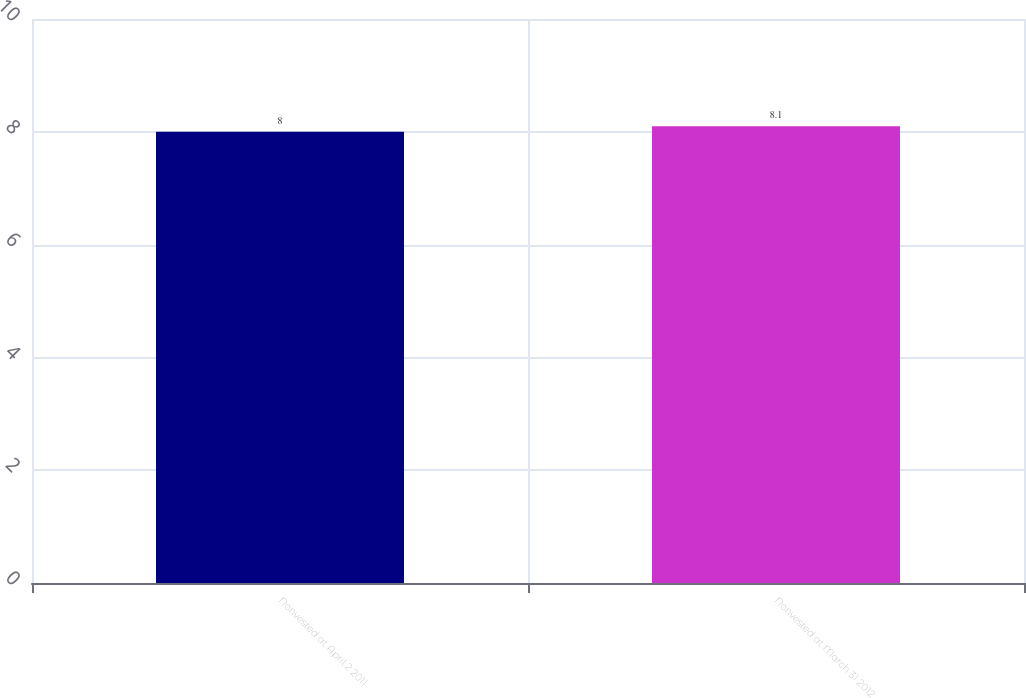<chart> <loc_0><loc_0><loc_500><loc_500><bar_chart><fcel>Nonvested at April 2 2011<fcel>Nonvested at March 31 2012<nl><fcel>8<fcel>8.1<nl></chart> 